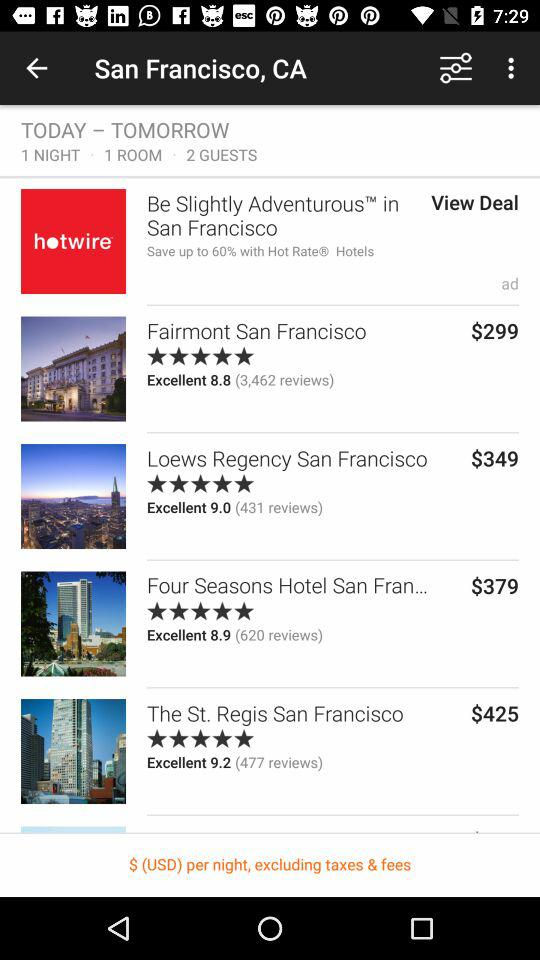How many people have given reviews of "Four Seasons Hotel"? The review is given by 620 people. 